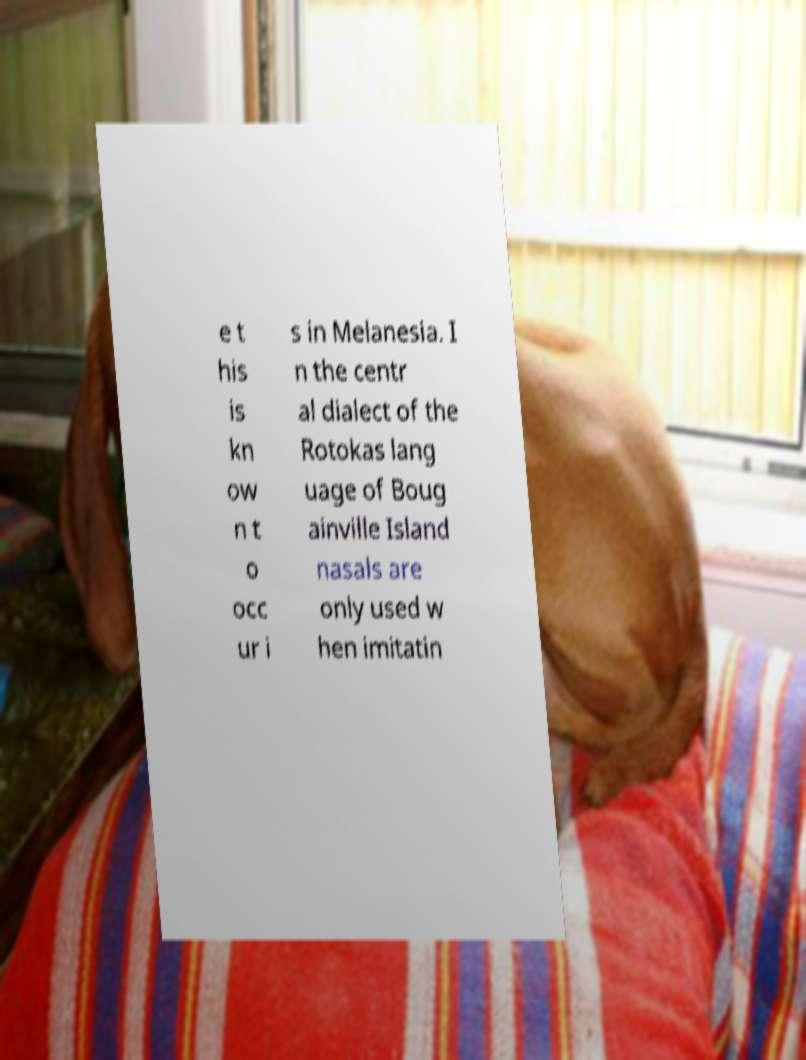There's text embedded in this image that I need extracted. Can you transcribe it verbatim? e t his is kn ow n t o occ ur i s in Melanesia. I n the centr al dialect of the Rotokas lang uage of Boug ainville Island nasals are only used w hen imitatin 